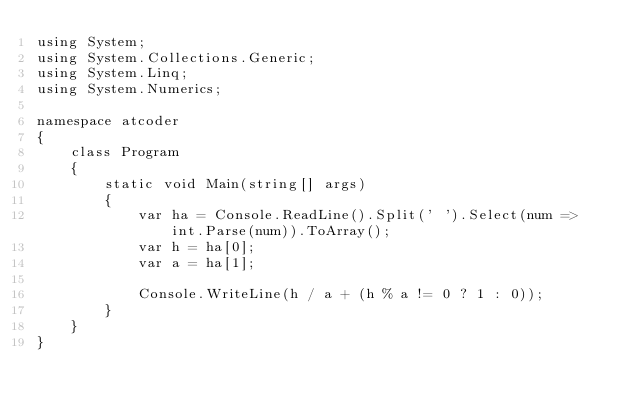Convert code to text. <code><loc_0><loc_0><loc_500><loc_500><_C#_>using System;
using System.Collections.Generic;
using System.Linq;
using System.Numerics;

namespace atcoder
{
    class Program
    {
        static void Main(string[] args)
        {
            var ha = Console.ReadLine().Split(' ').Select(num => int.Parse(num)).ToArray();
            var h = ha[0];
            var a = ha[1];

            Console.WriteLine(h / a + (h % a != 0 ? 1 : 0));
        }
    }
}</code> 